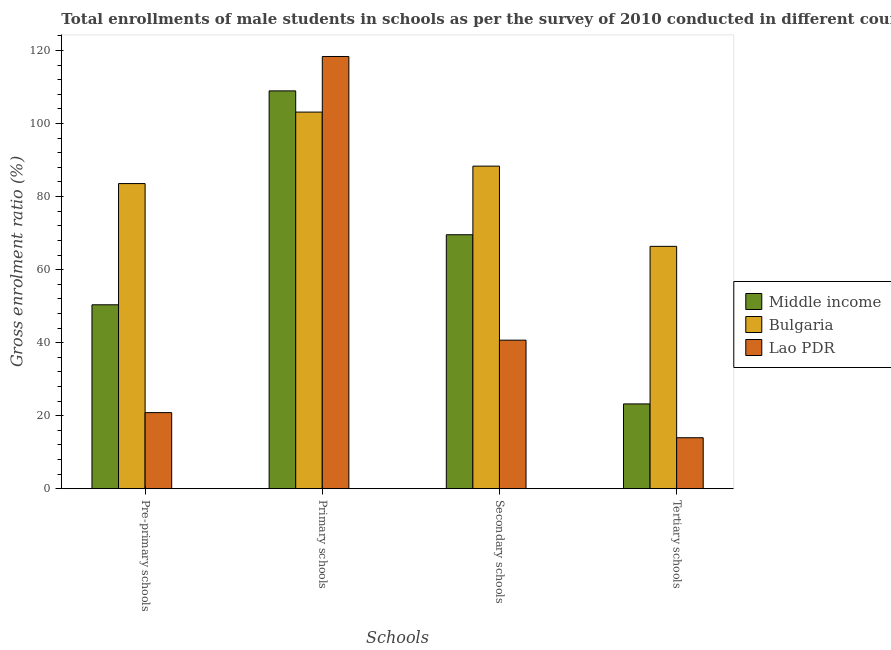How many groups of bars are there?
Make the answer very short. 4. Are the number of bars per tick equal to the number of legend labels?
Your response must be concise. Yes. How many bars are there on the 4th tick from the right?
Your answer should be compact. 3. What is the label of the 2nd group of bars from the left?
Your answer should be very brief. Primary schools. What is the gross enrolment ratio(male) in primary schools in Bulgaria?
Provide a succinct answer. 103.15. Across all countries, what is the maximum gross enrolment ratio(male) in secondary schools?
Your response must be concise. 88.34. Across all countries, what is the minimum gross enrolment ratio(male) in tertiary schools?
Keep it short and to the point. 13.95. In which country was the gross enrolment ratio(male) in primary schools minimum?
Keep it short and to the point. Bulgaria. What is the total gross enrolment ratio(male) in primary schools in the graph?
Provide a short and direct response. 330.48. What is the difference between the gross enrolment ratio(male) in secondary schools in Bulgaria and that in Middle income?
Your answer should be compact. 18.79. What is the difference between the gross enrolment ratio(male) in primary schools in Bulgaria and the gross enrolment ratio(male) in tertiary schools in Lao PDR?
Make the answer very short. 89.2. What is the average gross enrolment ratio(male) in secondary schools per country?
Provide a short and direct response. 66.19. What is the difference between the gross enrolment ratio(male) in primary schools and gross enrolment ratio(male) in secondary schools in Lao PDR?
Make the answer very short. 77.7. What is the ratio of the gross enrolment ratio(male) in tertiary schools in Bulgaria to that in Middle income?
Ensure brevity in your answer.  2.86. What is the difference between the highest and the second highest gross enrolment ratio(male) in secondary schools?
Your answer should be very brief. 18.79. What is the difference between the highest and the lowest gross enrolment ratio(male) in pre-primary schools?
Keep it short and to the point. 62.74. In how many countries, is the gross enrolment ratio(male) in pre-primary schools greater than the average gross enrolment ratio(male) in pre-primary schools taken over all countries?
Provide a short and direct response. 1. What does the 3rd bar from the left in Secondary schools represents?
Your answer should be very brief. Lao PDR. What does the 3rd bar from the right in Secondary schools represents?
Keep it short and to the point. Middle income. How many bars are there?
Ensure brevity in your answer.  12. What is the difference between two consecutive major ticks on the Y-axis?
Offer a terse response. 20. Are the values on the major ticks of Y-axis written in scientific E-notation?
Offer a very short reply. No. Does the graph contain any zero values?
Keep it short and to the point. No. Does the graph contain grids?
Keep it short and to the point. No. What is the title of the graph?
Keep it short and to the point. Total enrollments of male students in schools as per the survey of 2010 conducted in different countries. Does "Liechtenstein" appear as one of the legend labels in the graph?
Your answer should be very brief. No. What is the label or title of the X-axis?
Provide a succinct answer. Schools. What is the Gross enrolment ratio (%) in Middle income in Pre-primary schools?
Your answer should be very brief. 50.36. What is the Gross enrolment ratio (%) in Bulgaria in Pre-primary schools?
Your answer should be compact. 83.57. What is the Gross enrolment ratio (%) in Lao PDR in Pre-primary schools?
Offer a terse response. 20.83. What is the Gross enrolment ratio (%) of Middle income in Primary schools?
Keep it short and to the point. 108.95. What is the Gross enrolment ratio (%) of Bulgaria in Primary schools?
Make the answer very short. 103.15. What is the Gross enrolment ratio (%) in Lao PDR in Primary schools?
Your answer should be compact. 118.38. What is the Gross enrolment ratio (%) of Middle income in Secondary schools?
Keep it short and to the point. 69.55. What is the Gross enrolment ratio (%) of Bulgaria in Secondary schools?
Give a very brief answer. 88.34. What is the Gross enrolment ratio (%) of Lao PDR in Secondary schools?
Provide a succinct answer. 40.68. What is the Gross enrolment ratio (%) of Middle income in Tertiary schools?
Ensure brevity in your answer.  23.22. What is the Gross enrolment ratio (%) in Bulgaria in Tertiary schools?
Offer a terse response. 66.37. What is the Gross enrolment ratio (%) in Lao PDR in Tertiary schools?
Your response must be concise. 13.95. Across all Schools, what is the maximum Gross enrolment ratio (%) of Middle income?
Offer a terse response. 108.95. Across all Schools, what is the maximum Gross enrolment ratio (%) of Bulgaria?
Offer a very short reply. 103.15. Across all Schools, what is the maximum Gross enrolment ratio (%) of Lao PDR?
Your answer should be very brief. 118.38. Across all Schools, what is the minimum Gross enrolment ratio (%) of Middle income?
Provide a succinct answer. 23.22. Across all Schools, what is the minimum Gross enrolment ratio (%) of Bulgaria?
Offer a terse response. 66.37. Across all Schools, what is the minimum Gross enrolment ratio (%) of Lao PDR?
Your answer should be compact. 13.95. What is the total Gross enrolment ratio (%) of Middle income in the graph?
Offer a very short reply. 252.09. What is the total Gross enrolment ratio (%) in Bulgaria in the graph?
Make the answer very short. 341.43. What is the total Gross enrolment ratio (%) of Lao PDR in the graph?
Your answer should be very brief. 193.83. What is the difference between the Gross enrolment ratio (%) in Middle income in Pre-primary schools and that in Primary schools?
Your answer should be compact. -58.59. What is the difference between the Gross enrolment ratio (%) of Bulgaria in Pre-primary schools and that in Primary schools?
Make the answer very short. -19.58. What is the difference between the Gross enrolment ratio (%) in Lao PDR in Pre-primary schools and that in Primary schools?
Ensure brevity in your answer.  -97.54. What is the difference between the Gross enrolment ratio (%) in Middle income in Pre-primary schools and that in Secondary schools?
Provide a short and direct response. -19.19. What is the difference between the Gross enrolment ratio (%) in Bulgaria in Pre-primary schools and that in Secondary schools?
Keep it short and to the point. -4.77. What is the difference between the Gross enrolment ratio (%) in Lao PDR in Pre-primary schools and that in Secondary schools?
Provide a succinct answer. -19.84. What is the difference between the Gross enrolment ratio (%) in Middle income in Pre-primary schools and that in Tertiary schools?
Offer a terse response. 27.15. What is the difference between the Gross enrolment ratio (%) of Bulgaria in Pre-primary schools and that in Tertiary schools?
Make the answer very short. 17.2. What is the difference between the Gross enrolment ratio (%) in Lao PDR in Pre-primary schools and that in Tertiary schools?
Your answer should be compact. 6.88. What is the difference between the Gross enrolment ratio (%) in Middle income in Primary schools and that in Secondary schools?
Ensure brevity in your answer.  39.4. What is the difference between the Gross enrolment ratio (%) of Bulgaria in Primary schools and that in Secondary schools?
Provide a succinct answer. 14.81. What is the difference between the Gross enrolment ratio (%) of Lao PDR in Primary schools and that in Secondary schools?
Offer a terse response. 77.7. What is the difference between the Gross enrolment ratio (%) of Middle income in Primary schools and that in Tertiary schools?
Ensure brevity in your answer.  85.74. What is the difference between the Gross enrolment ratio (%) of Bulgaria in Primary schools and that in Tertiary schools?
Provide a succinct answer. 36.78. What is the difference between the Gross enrolment ratio (%) in Lao PDR in Primary schools and that in Tertiary schools?
Offer a terse response. 104.43. What is the difference between the Gross enrolment ratio (%) of Middle income in Secondary schools and that in Tertiary schools?
Offer a very short reply. 46.34. What is the difference between the Gross enrolment ratio (%) of Bulgaria in Secondary schools and that in Tertiary schools?
Keep it short and to the point. 21.97. What is the difference between the Gross enrolment ratio (%) of Lao PDR in Secondary schools and that in Tertiary schools?
Your answer should be compact. 26.73. What is the difference between the Gross enrolment ratio (%) of Middle income in Pre-primary schools and the Gross enrolment ratio (%) of Bulgaria in Primary schools?
Keep it short and to the point. -52.78. What is the difference between the Gross enrolment ratio (%) of Middle income in Pre-primary schools and the Gross enrolment ratio (%) of Lao PDR in Primary schools?
Your response must be concise. -68.01. What is the difference between the Gross enrolment ratio (%) of Bulgaria in Pre-primary schools and the Gross enrolment ratio (%) of Lao PDR in Primary schools?
Make the answer very short. -34.81. What is the difference between the Gross enrolment ratio (%) in Middle income in Pre-primary schools and the Gross enrolment ratio (%) in Bulgaria in Secondary schools?
Make the answer very short. -37.98. What is the difference between the Gross enrolment ratio (%) of Middle income in Pre-primary schools and the Gross enrolment ratio (%) of Lao PDR in Secondary schools?
Ensure brevity in your answer.  9.69. What is the difference between the Gross enrolment ratio (%) of Bulgaria in Pre-primary schools and the Gross enrolment ratio (%) of Lao PDR in Secondary schools?
Your response must be concise. 42.89. What is the difference between the Gross enrolment ratio (%) in Middle income in Pre-primary schools and the Gross enrolment ratio (%) in Bulgaria in Tertiary schools?
Provide a short and direct response. -16.01. What is the difference between the Gross enrolment ratio (%) in Middle income in Pre-primary schools and the Gross enrolment ratio (%) in Lao PDR in Tertiary schools?
Ensure brevity in your answer.  36.41. What is the difference between the Gross enrolment ratio (%) of Bulgaria in Pre-primary schools and the Gross enrolment ratio (%) of Lao PDR in Tertiary schools?
Your answer should be compact. 69.62. What is the difference between the Gross enrolment ratio (%) of Middle income in Primary schools and the Gross enrolment ratio (%) of Bulgaria in Secondary schools?
Offer a terse response. 20.61. What is the difference between the Gross enrolment ratio (%) of Middle income in Primary schools and the Gross enrolment ratio (%) of Lao PDR in Secondary schools?
Keep it short and to the point. 68.28. What is the difference between the Gross enrolment ratio (%) of Bulgaria in Primary schools and the Gross enrolment ratio (%) of Lao PDR in Secondary schools?
Keep it short and to the point. 62.47. What is the difference between the Gross enrolment ratio (%) of Middle income in Primary schools and the Gross enrolment ratio (%) of Bulgaria in Tertiary schools?
Offer a terse response. 42.58. What is the difference between the Gross enrolment ratio (%) in Middle income in Primary schools and the Gross enrolment ratio (%) in Lao PDR in Tertiary schools?
Your answer should be compact. 95. What is the difference between the Gross enrolment ratio (%) of Bulgaria in Primary schools and the Gross enrolment ratio (%) of Lao PDR in Tertiary schools?
Make the answer very short. 89.2. What is the difference between the Gross enrolment ratio (%) of Middle income in Secondary schools and the Gross enrolment ratio (%) of Bulgaria in Tertiary schools?
Ensure brevity in your answer.  3.18. What is the difference between the Gross enrolment ratio (%) of Middle income in Secondary schools and the Gross enrolment ratio (%) of Lao PDR in Tertiary schools?
Give a very brief answer. 55.6. What is the difference between the Gross enrolment ratio (%) of Bulgaria in Secondary schools and the Gross enrolment ratio (%) of Lao PDR in Tertiary schools?
Keep it short and to the point. 74.39. What is the average Gross enrolment ratio (%) of Middle income per Schools?
Provide a succinct answer. 63.02. What is the average Gross enrolment ratio (%) of Bulgaria per Schools?
Keep it short and to the point. 85.36. What is the average Gross enrolment ratio (%) in Lao PDR per Schools?
Make the answer very short. 48.46. What is the difference between the Gross enrolment ratio (%) in Middle income and Gross enrolment ratio (%) in Bulgaria in Pre-primary schools?
Your answer should be compact. -33.2. What is the difference between the Gross enrolment ratio (%) in Middle income and Gross enrolment ratio (%) in Lao PDR in Pre-primary schools?
Offer a terse response. 29.53. What is the difference between the Gross enrolment ratio (%) in Bulgaria and Gross enrolment ratio (%) in Lao PDR in Pre-primary schools?
Your response must be concise. 62.74. What is the difference between the Gross enrolment ratio (%) in Middle income and Gross enrolment ratio (%) in Bulgaria in Primary schools?
Provide a succinct answer. 5.81. What is the difference between the Gross enrolment ratio (%) in Middle income and Gross enrolment ratio (%) in Lao PDR in Primary schools?
Offer a terse response. -9.42. What is the difference between the Gross enrolment ratio (%) in Bulgaria and Gross enrolment ratio (%) in Lao PDR in Primary schools?
Ensure brevity in your answer.  -15.23. What is the difference between the Gross enrolment ratio (%) of Middle income and Gross enrolment ratio (%) of Bulgaria in Secondary schools?
Offer a very short reply. -18.79. What is the difference between the Gross enrolment ratio (%) in Middle income and Gross enrolment ratio (%) in Lao PDR in Secondary schools?
Offer a very short reply. 28.88. What is the difference between the Gross enrolment ratio (%) of Bulgaria and Gross enrolment ratio (%) of Lao PDR in Secondary schools?
Your answer should be very brief. 47.67. What is the difference between the Gross enrolment ratio (%) of Middle income and Gross enrolment ratio (%) of Bulgaria in Tertiary schools?
Provide a succinct answer. -43.15. What is the difference between the Gross enrolment ratio (%) of Middle income and Gross enrolment ratio (%) of Lao PDR in Tertiary schools?
Your answer should be compact. 9.27. What is the difference between the Gross enrolment ratio (%) of Bulgaria and Gross enrolment ratio (%) of Lao PDR in Tertiary schools?
Keep it short and to the point. 52.42. What is the ratio of the Gross enrolment ratio (%) of Middle income in Pre-primary schools to that in Primary schools?
Keep it short and to the point. 0.46. What is the ratio of the Gross enrolment ratio (%) in Bulgaria in Pre-primary schools to that in Primary schools?
Give a very brief answer. 0.81. What is the ratio of the Gross enrolment ratio (%) of Lao PDR in Pre-primary schools to that in Primary schools?
Your response must be concise. 0.18. What is the ratio of the Gross enrolment ratio (%) of Middle income in Pre-primary schools to that in Secondary schools?
Provide a succinct answer. 0.72. What is the ratio of the Gross enrolment ratio (%) in Bulgaria in Pre-primary schools to that in Secondary schools?
Your answer should be very brief. 0.95. What is the ratio of the Gross enrolment ratio (%) of Lao PDR in Pre-primary schools to that in Secondary schools?
Your response must be concise. 0.51. What is the ratio of the Gross enrolment ratio (%) of Middle income in Pre-primary schools to that in Tertiary schools?
Your answer should be very brief. 2.17. What is the ratio of the Gross enrolment ratio (%) in Bulgaria in Pre-primary schools to that in Tertiary schools?
Keep it short and to the point. 1.26. What is the ratio of the Gross enrolment ratio (%) in Lao PDR in Pre-primary schools to that in Tertiary schools?
Make the answer very short. 1.49. What is the ratio of the Gross enrolment ratio (%) in Middle income in Primary schools to that in Secondary schools?
Your answer should be very brief. 1.57. What is the ratio of the Gross enrolment ratio (%) of Bulgaria in Primary schools to that in Secondary schools?
Provide a short and direct response. 1.17. What is the ratio of the Gross enrolment ratio (%) in Lao PDR in Primary schools to that in Secondary schools?
Offer a very short reply. 2.91. What is the ratio of the Gross enrolment ratio (%) of Middle income in Primary schools to that in Tertiary schools?
Offer a terse response. 4.69. What is the ratio of the Gross enrolment ratio (%) of Bulgaria in Primary schools to that in Tertiary schools?
Your response must be concise. 1.55. What is the ratio of the Gross enrolment ratio (%) in Lao PDR in Primary schools to that in Tertiary schools?
Your response must be concise. 8.49. What is the ratio of the Gross enrolment ratio (%) of Middle income in Secondary schools to that in Tertiary schools?
Give a very brief answer. 3. What is the ratio of the Gross enrolment ratio (%) of Bulgaria in Secondary schools to that in Tertiary schools?
Provide a short and direct response. 1.33. What is the ratio of the Gross enrolment ratio (%) of Lao PDR in Secondary schools to that in Tertiary schools?
Ensure brevity in your answer.  2.92. What is the difference between the highest and the second highest Gross enrolment ratio (%) in Middle income?
Provide a succinct answer. 39.4. What is the difference between the highest and the second highest Gross enrolment ratio (%) in Bulgaria?
Your answer should be very brief. 14.81. What is the difference between the highest and the second highest Gross enrolment ratio (%) in Lao PDR?
Your answer should be very brief. 77.7. What is the difference between the highest and the lowest Gross enrolment ratio (%) in Middle income?
Make the answer very short. 85.74. What is the difference between the highest and the lowest Gross enrolment ratio (%) in Bulgaria?
Your answer should be compact. 36.78. What is the difference between the highest and the lowest Gross enrolment ratio (%) of Lao PDR?
Offer a very short reply. 104.43. 